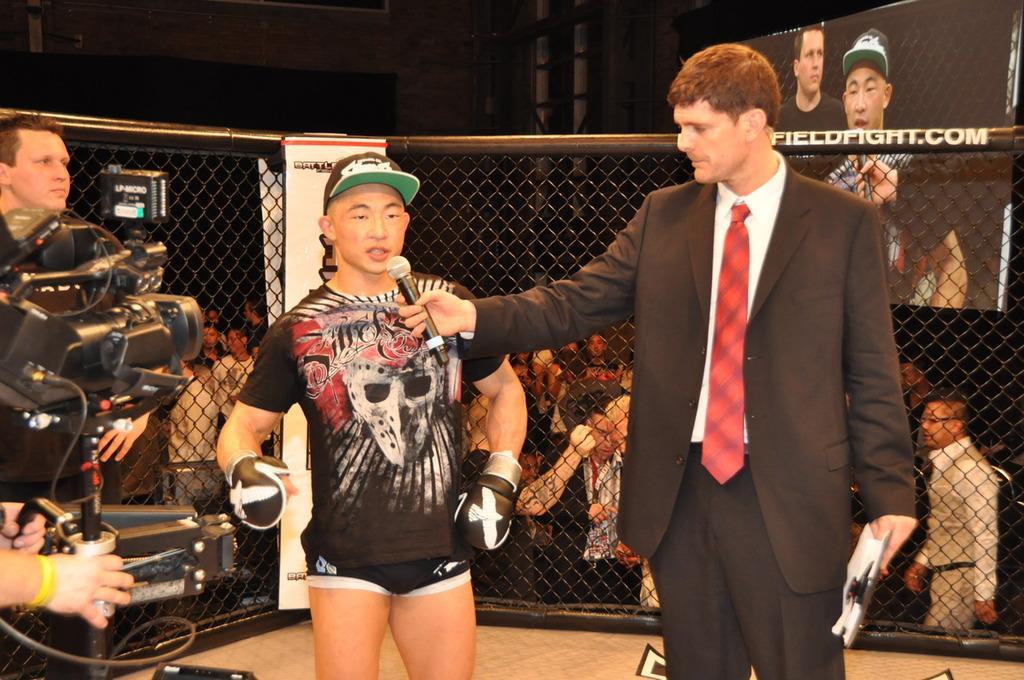Can you describe this image briefly? In this picture we can see some people, camera, cap, gloves and a man wore a blazer, tie and holding a mic with his hand and in the background we can see a group of people, fence, screen, wall and some objects. 